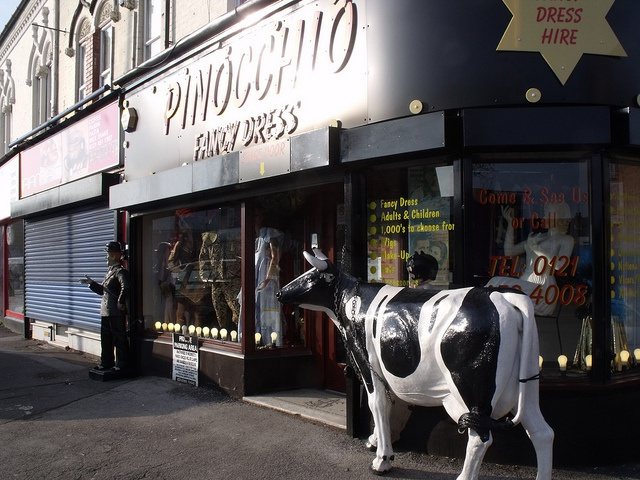Describe the objects in this image and their specific colors. I can see cow in lavender, black, gray, lightgray, and darkgray tones, people in lavender, black, gray, and darkgray tones, and chair in black, darkgray, and lavender tones in this image. 